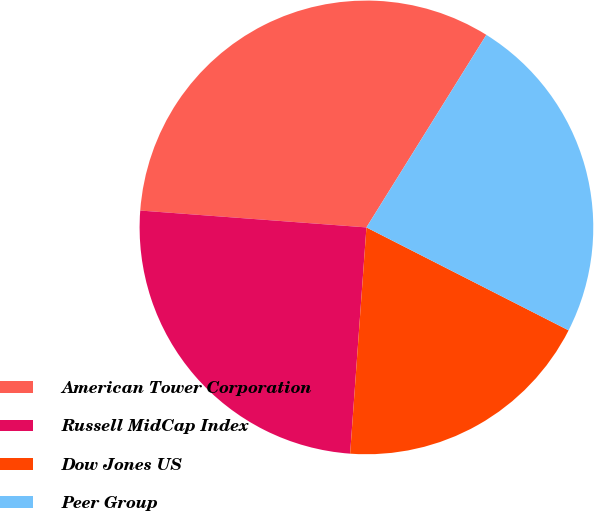Convert chart to OTSL. <chart><loc_0><loc_0><loc_500><loc_500><pie_chart><fcel>American Tower Corporation<fcel>Russell MidCap Index<fcel>Dow Jones US<fcel>Peer Group<nl><fcel>32.68%<fcel>25.04%<fcel>18.65%<fcel>23.63%<nl></chart> 